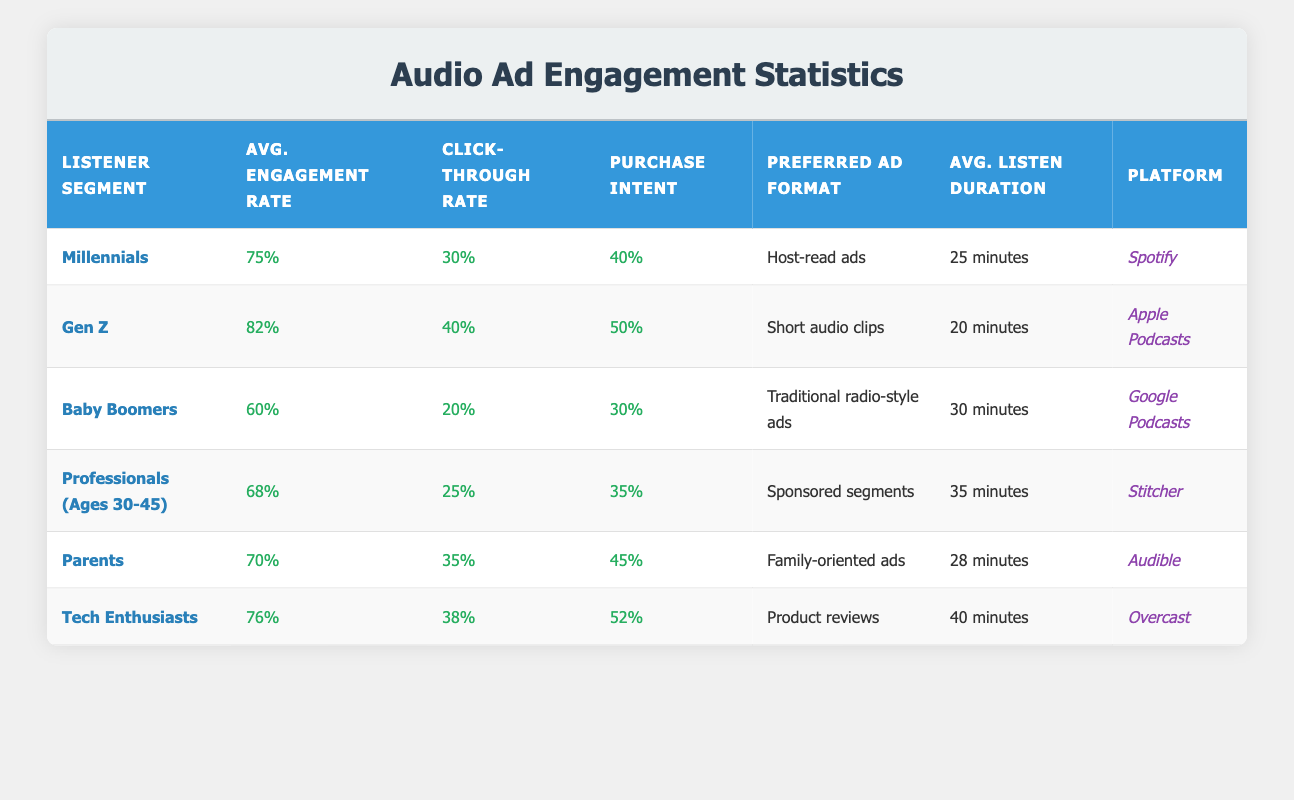What is the average engagement rate for Gen Z? From the table, the engagement rate for Gen Z is listed as 0.82 or 82%.
Answer: 82% Which listener segment has the highest click-through rate? By examining the click-through rates for all segments, Gen Z has the highest click-through rate at 40%.
Answer: Gen Z What is the preferred ad format for Tech Enthusiasts? The table shows that Tech Enthusiasts prefer "Product reviews" as their ad format.
Answer: Product reviews Are Baby Boomers more likely to make a purchase than Parents? Baby Boomers have a purchase intent of 30%, while Parents have a purchase intent of 45%. Therefore, Parents are more likely to make a purchase.
Answer: No What is the difference in average listen duration between Tech Enthusiasts and Millennials? Tech Enthusiasts have an average listen duration of 40 minutes, while Millennials have 25 minutes. The difference is 40 - 25 = 15 minutes.
Answer: 15 minutes Is the average engagement rate for Professionals (Ages 30-45) higher than that for Baby Boomers? The average engagement rate for Professionals is 68%, while for Baby Boomers, it is 60%. Since 68% is greater than 60%, the answer is yes.
Answer: Yes What is the average purchase intent across all listener segments? Adding all the purchase intents: (0.40 + 0.50 + 0.30 + 0.35 + 0.45 + 0.52) = 2.52 and dividing by 6 segments gives an average of 2.52/6 = 0.42 or 42%.
Answer: 42% Which segment has the lowest average listen duration and what is that duration? By checking each segment, Millennials have the lowest average listen duration at 25 minutes.
Answer: 25 minutes What platform do Professionals (Ages 30-45) primarily use? According to the table, Professionals (Ages 30-45) primarily use Stitcher as their platform.
Answer: Stitcher 